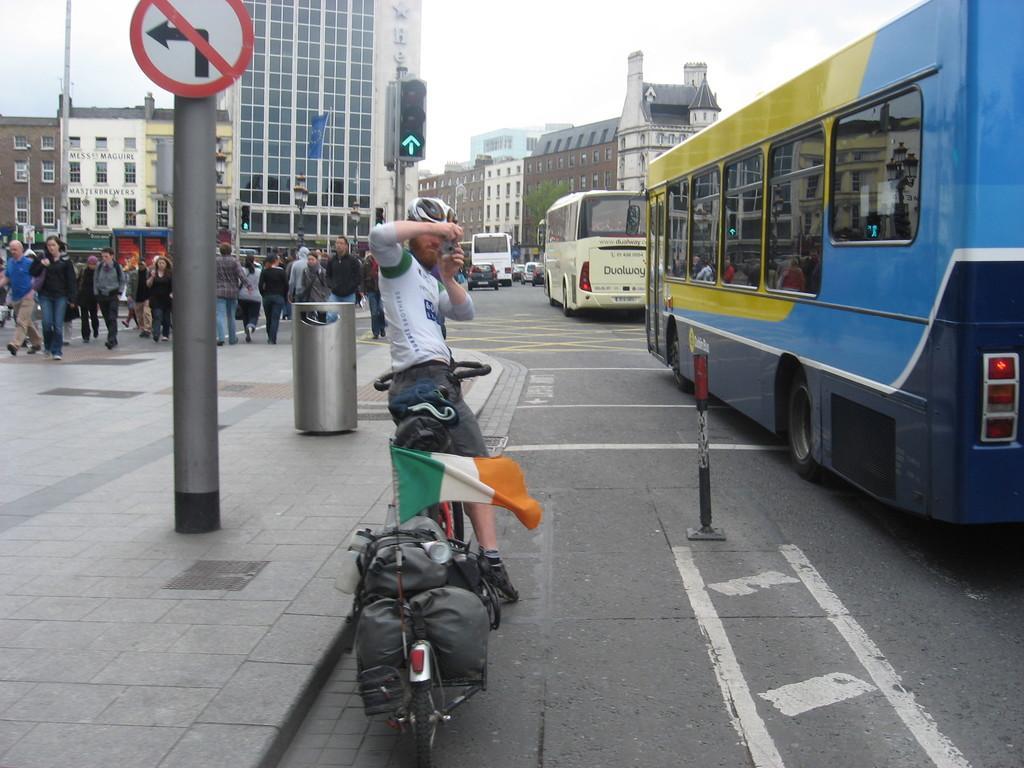How would you summarize this image in a sentence or two? In this image I can see few roads and on it I can see number of vehicles, number of people and in the front I can see one man is standing on his bicycle. On the backside of the bicycle I can see few bags and a flag. I can also see he is holding a camera and I can see he is wearing a helmet, white colour dress and shorts. On the left side of this image I can see few moles, a sign board and signal lights. In the background I can see number of buildings, the sky and a flag. 